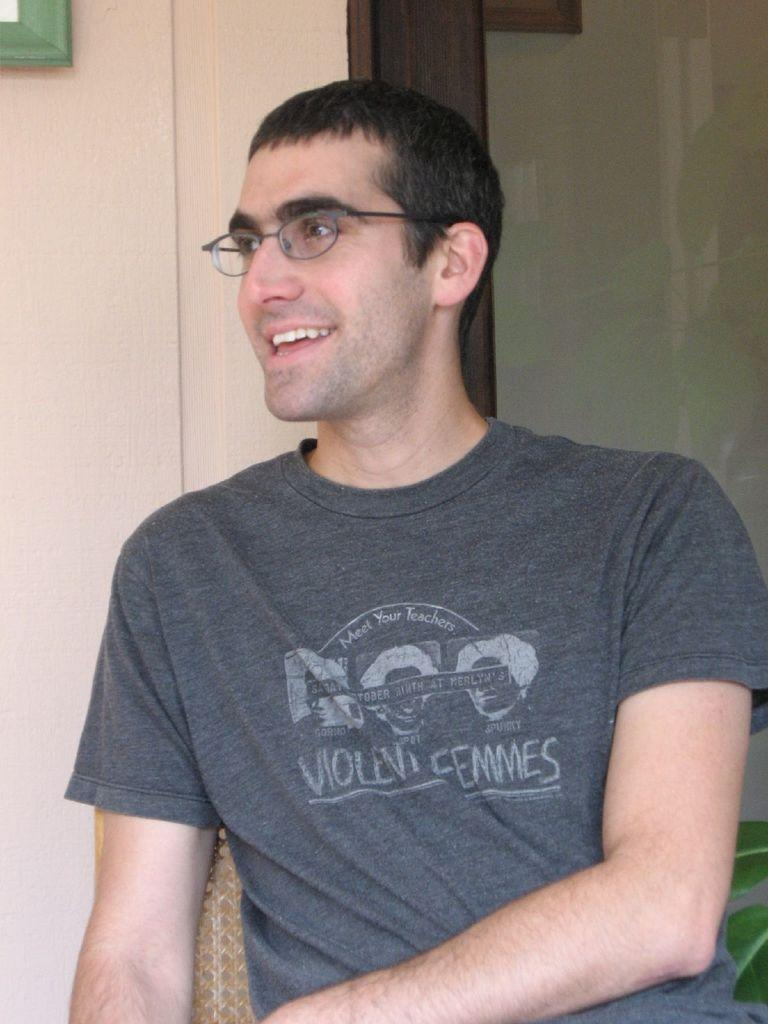What is the main subject of the image? There is a person in the image. What is the person doing in the image? The person is sitting on a chair. How does the person appear to be feeling in the image? The person has a smile on their face, suggesting they are happy or content. What direction is the person looking in the image? The person is looking to the left of the image. What can be seen behind the person in the image? There is a wall and a glass door behind the person. What type of yoke is the person holding in the image? There is no yoke present in the image; the person is sitting on a chair and looking to the left. 